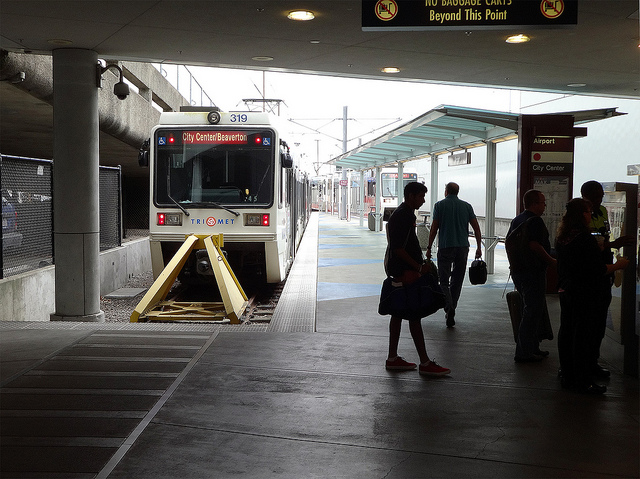<image>What color is the fence? I am not sure what the color of the fence is. It can be gray or black. What color is the fence? I am not sure what color is the fence. It can be seen gray or black. 